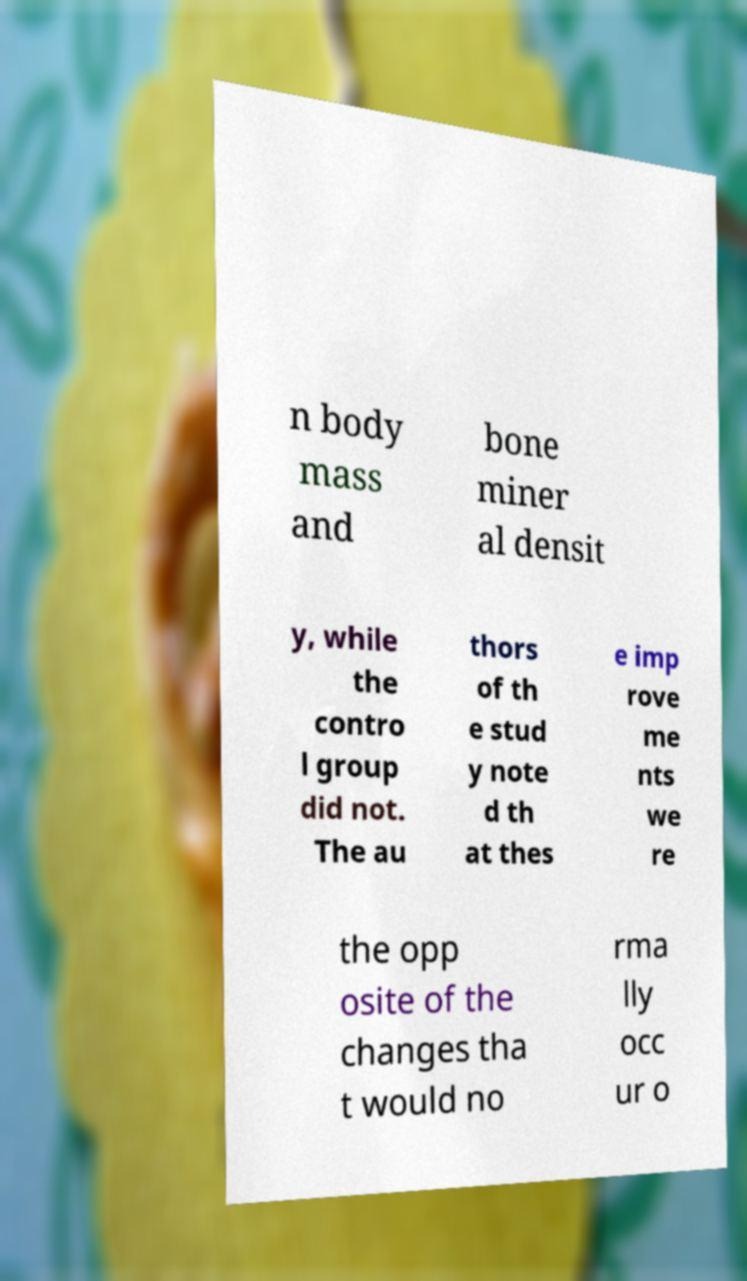Please identify and transcribe the text found in this image. n body mass and bone miner al densit y, while the contro l group did not. The au thors of th e stud y note d th at thes e imp rove me nts we re the opp osite of the changes tha t would no rma lly occ ur o 